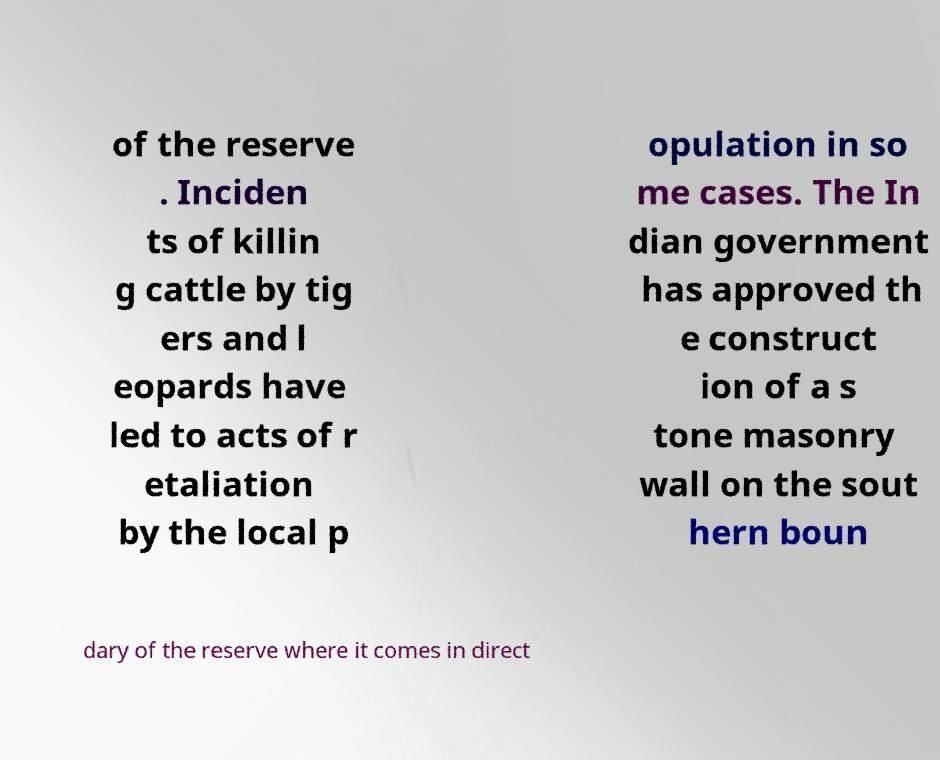I need the written content from this picture converted into text. Can you do that? of the reserve . Inciden ts of killin g cattle by tig ers and l eopards have led to acts of r etaliation by the local p opulation in so me cases. The In dian government has approved th e construct ion of a s tone masonry wall on the sout hern boun dary of the reserve where it comes in direct 